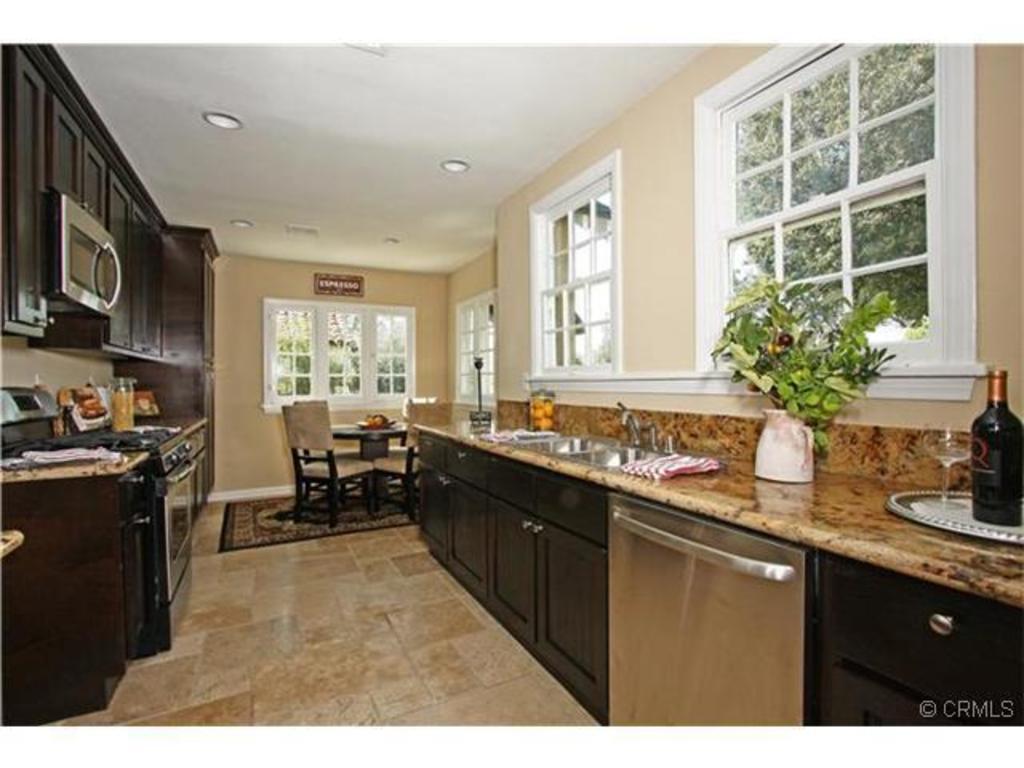Please provide a concise description of this image. In this image I can see the inner view of room, where we can see there is a table with so many objects and wash basin in the middle, on the left side there are so many other things, also there is a dining table beside the wall. 